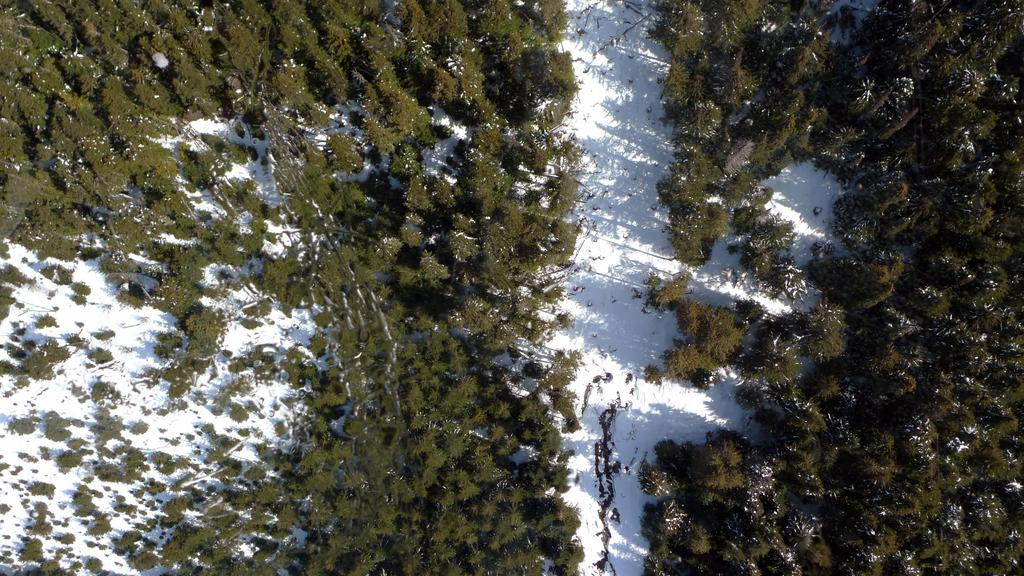What perspective is the image taken from? The image is a top view. What type of vegetation can be seen in the image? There are trees in the image. What weather condition is depicted in the image? There is snow in the image. What emotion is the snow expressing in the image? The snow does not express emotions in the image; it is a natural weather condition. 